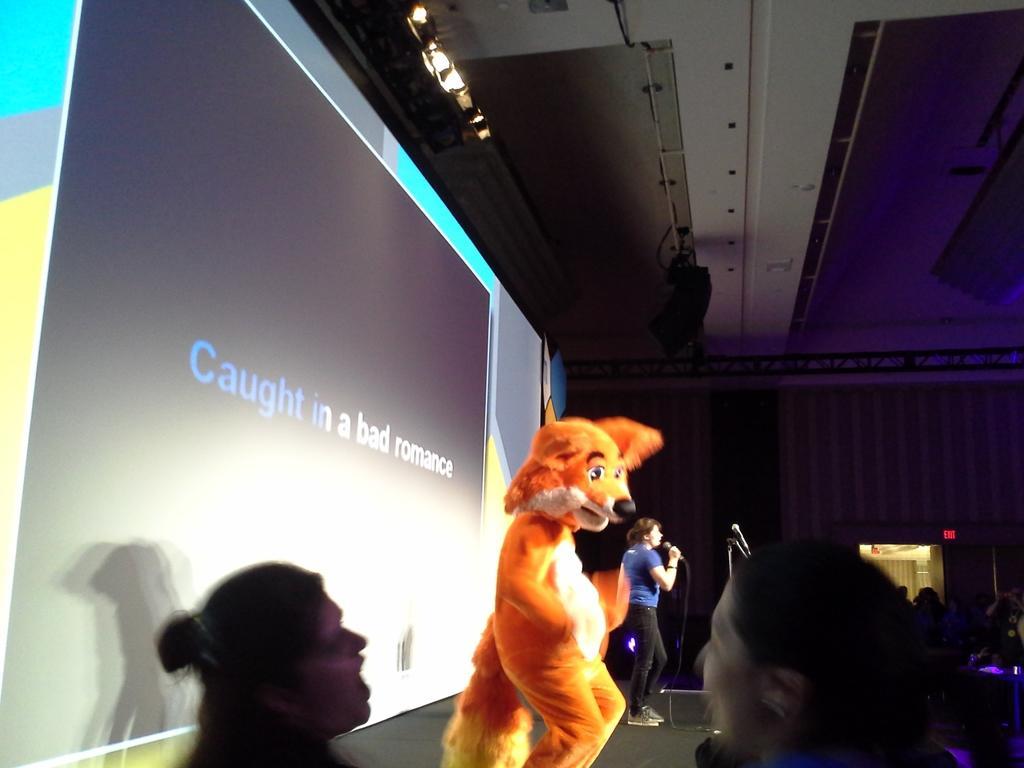Describe this image in one or two sentences. In this picture there are people, among them there is a woman holding a microphone and we can see mascot, microphone with stand and screen. In the background of the image we can see a board and wall. At the top we can see lights and rods. 